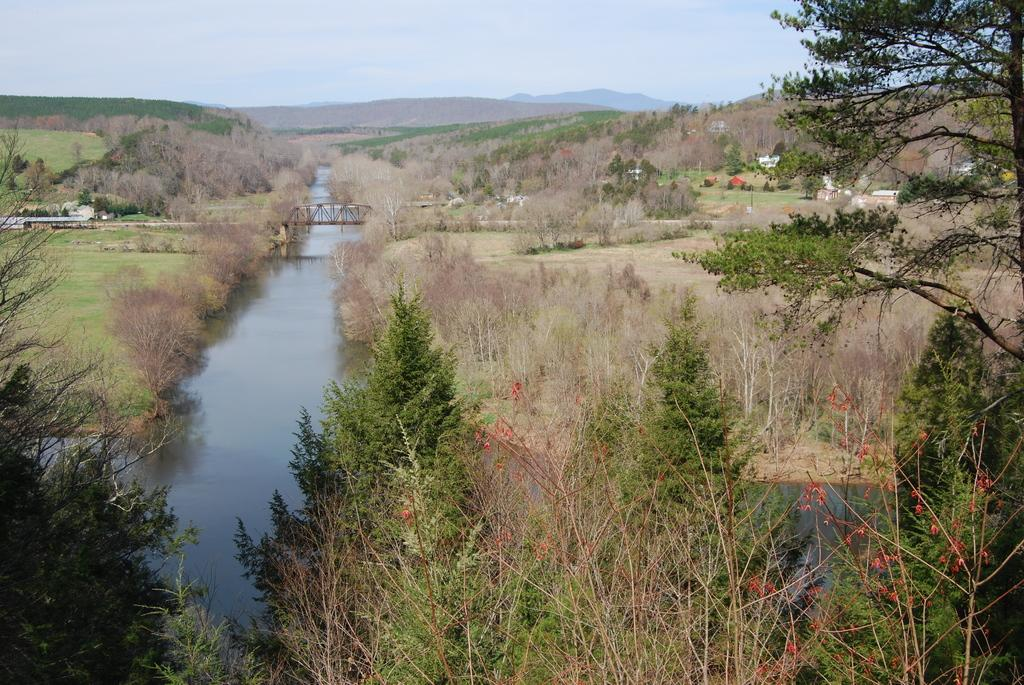What structure can be seen in the image? There is a bridge in the image. What is visible beneath the bridge? Water is visible in the image. What can be seen on the right side of the bridge? There are trees and houses on the right side of the bridge. What type of landscape is visible at the top of the image? There are hills visible at the top of the image. What is the condition of the sky in the image? The sky is cloudy and visible at the top of the image. Where is the wristwatch placed in the image? There is no wristwatch present in the image. What type of place is depicted in the image? The image does not depict a specific place; it shows a bridge, water, trees, houses, hills, and a cloudy sky. 